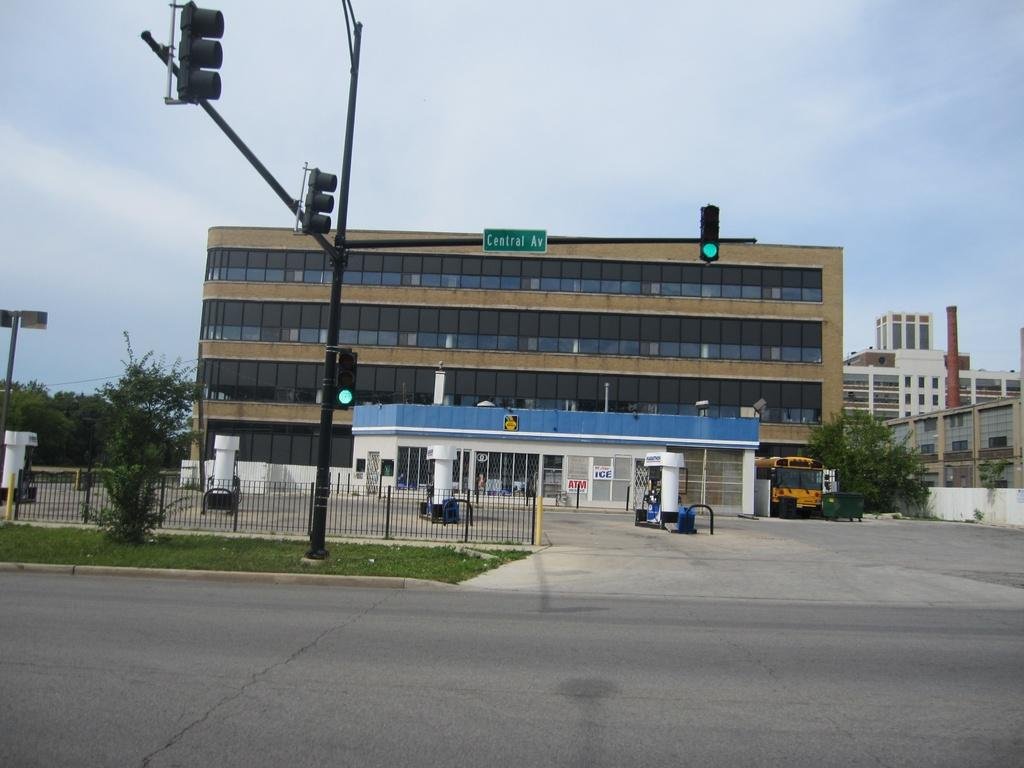What type of structures can be seen in the image? There are buildings in the image. What natural elements are present in the image? There are trees and grass in the image. What man-made objects can be seen in the image? There are poles, traffic signals, boards, a fence, and a vehicle in the image. What is the primary function of the poles and traffic signals in the image? The poles and traffic signals are likely used for traffic control. What is the surface on which the vehicle is traveling in the image? This is a road. What can be seen in the background of the image? The sky is visible in the background of the image. How does the woman increase her payment in the image? There is no woman present in the image, and therefore no payment can be increased. What type of payment is being made in the image? There is no payment being made in the image. 